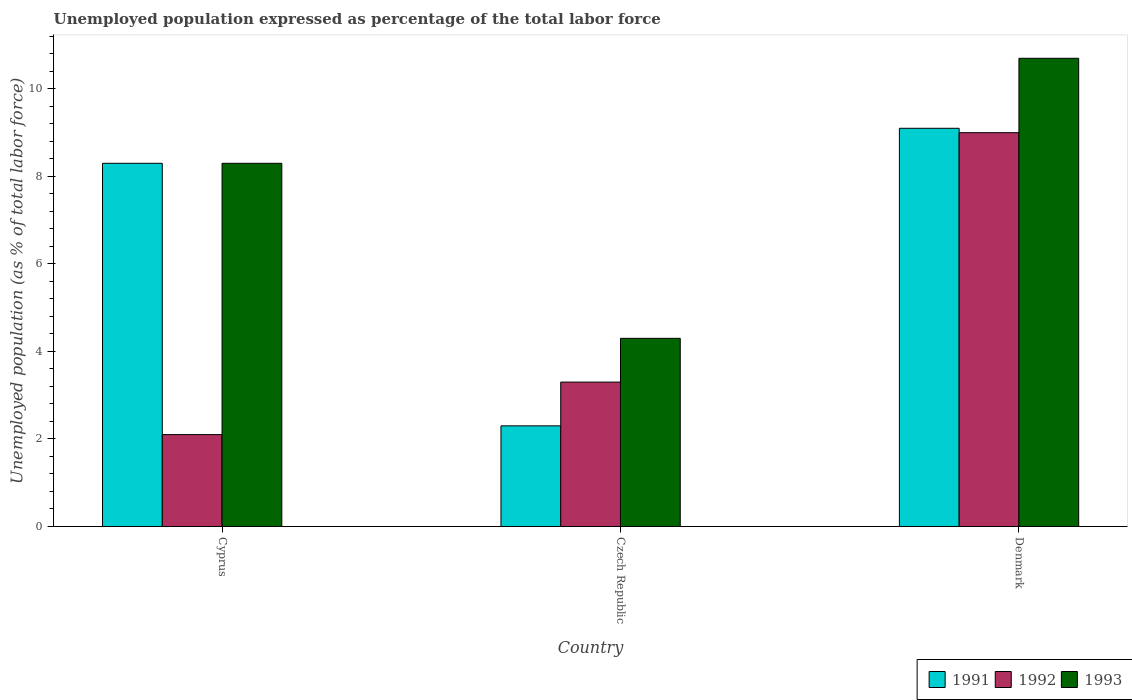How many groups of bars are there?
Offer a terse response. 3. Are the number of bars per tick equal to the number of legend labels?
Provide a succinct answer. Yes. What is the label of the 2nd group of bars from the left?
Your answer should be very brief. Czech Republic. In how many cases, is the number of bars for a given country not equal to the number of legend labels?
Your response must be concise. 0. What is the unemployment in in 1992 in Cyprus?
Offer a very short reply. 2.1. Across all countries, what is the maximum unemployment in in 1992?
Offer a very short reply. 9. Across all countries, what is the minimum unemployment in in 1992?
Provide a succinct answer. 2.1. In which country was the unemployment in in 1991 minimum?
Your answer should be compact. Czech Republic. What is the total unemployment in in 1992 in the graph?
Ensure brevity in your answer.  14.4. What is the difference between the unemployment in in 1992 in Cyprus and that in Czech Republic?
Your response must be concise. -1.2. What is the difference between the unemployment in in 1993 in Cyprus and the unemployment in in 1992 in Denmark?
Provide a succinct answer. -0.7. What is the average unemployment in in 1991 per country?
Offer a terse response. 6.57. What is the difference between the unemployment in of/in 1993 and unemployment in of/in 1992 in Cyprus?
Offer a terse response. 6.2. In how many countries, is the unemployment in in 1992 greater than 4 %?
Keep it short and to the point. 1. What is the ratio of the unemployment in in 1993 in Cyprus to that in Czech Republic?
Offer a very short reply. 1.93. Is the difference between the unemployment in in 1993 in Cyprus and Denmark greater than the difference between the unemployment in in 1992 in Cyprus and Denmark?
Ensure brevity in your answer.  Yes. What is the difference between the highest and the second highest unemployment in in 1993?
Your answer should be very brief. -2.4. What is the difference between the highest and the lowest unemployment in in 1991?
Provide a succinct answer. 6.8. In how many countries, is the unemployment in in 1991 greater than the average unemployment in in 1991 taken over all countries?
Offer a very short reply. 2. What does the 1st bar from the left in Cyprus represents?
Ensure brevity in your answer.  1991. What does the 2nd bar from the right in Denmark represents?
Your response must be concise. 1992. How many countries are there in the graph?
Offer a terse response. 3. What is the difference between two consecutive major ticks on the Y-axis?
Keep it short and to the point. 2. Are the values on the major ticks of Y-axis written in scientific E-notation?
Offer a terse response. No. Does the graph contain any zero values?
Your answer should be very brief. No. Does the graph contain grids?
Provide a succinct answer. No. Where does the legend appear in the graph?
Keep it short and to the point. Bottom right. What is the title of the graph?
Ensure brevity in your answer.  Unemployed population expressed as percentage of the total labor force. Does "1961" appear as one of the legend labels in the graph?
Provide a succinct answer. No. What is the label or title of the X-axis?
Make the answer very short. Country. What is the label or title of the Y-axis?
Offer a very short reply. Unemployed population (as % of total labor force). What is the Unemployed population (as % of total labor force) of 1991 in Cyprus?
Provide a short and direct response. 8.3. What is the Unemployed population (as % of total labor force) in 1992 in Cyprus?
Your answer should be very brief. 2.1. What is the Unemployed population (as % of total labor force) of 1993 in Cyprus?
Your answer should be very brief. 8.3. What is the Unemployed population (as % of total labor force) of 1991 in Czech Republic?
Offer a very short reply. 2.3. What is the Unemployed population (as % of total labor force) in 1992 in Czech Republic?
Provide a short and direct response. 3.3. What is the Unemployed population (as % of total labor force) in 1993 in Czech Republic?
Make the answer very short. 4.3. What is the Unemployed population (as % of total labor force) of 1991 in Denmark?
Keep it short and to the point. 9.1. What is the Unemployed population (as % of total labor force) in 1992 in Denmark?
Your answer should be very brief. 9. What is the Unemployed population (as % of total labor force) of 1993 in Denmark?
Your answer should be very brief. 10.7. Across all countries, what is the maximum Unemployed population (as % of total labor force) in 1991?
Ensure brevity in your answer.  9.1. Across all countries, what is the maximum Unemployed population (as % of total labor force) in 1992?
Your answer should be compact. 9. Across all countries, what is the maximum Unemployed population (as % of total labor force) of 1993?
Your answer should be compact. 10.7. Across all countries, what is the minimum Unemployed population (as % of total labor force) in 1991?
Ensure brevity in your answer.  2.3. Across all countries, what is the minimum Unemployed population (as % of total labor force) in 1992?
Give a very brief answer. 2.1. Across all countries, what is the minimum Unemployed population (as % of total labor force) in 1993?
Make the answer very short. 4.3. What is the total Unemployed population (as % of total labor force) of 1991 in the graph?
Offer a terse response. 19.7. What is the total Unemployed population (as % of total labor force) of 1992 in the graph?
Keep it short and to the point. 14.4. What is the total Unemployed population (as % of total labor force) of 1993 in the graph?
Keep it short and to the point. 23.3. What is the difference between the Unemployed population (as % of total labor force) of 1991 in Cyprus and that in Czech Republic?
Keep it short and to the point. 6. What is the difference between the Unemployed population (as % of total labor force) of 1992 in Cyprus and that in Czech Republic?
Ensure brevity in your answer.  -1.2. What is the difference between the Unemployed population (as % of total labor force) of 1991 in Cyprus and that in Denmark?
Your answer should be very brief. -0.8. What is the difference between the Unemployed population (as % of total labor force) in 1992 in Cyprus and that in Denmark?
Keep it short and to the point. -6.9. What is the difference between the Unemployed population (as % of total labor force) in 1991 in Czech Republic and that in Denmark?
Give a very brief answer. -6.8. What is the difference between the Unemployed population (as % of total labor force) of 1991 in Cyprus and the Unemployed population (as % of total labor force) of 1993 in Denmark?
Offer a very short reply. -2.4. What is the difference between the Unemployed population (as % of total labor force) in 1992 in Cyprus and the Unemployed population (as % of total labor force) in 1993 in Denmark?
Provide a succinct answer. -8.6. What is the difference between the Unemployed population (as % of total labor force) in 1991 in Czech Republic and the Unemployed population (as % of total labor force) in 1992 in Denmark?
Your answer should be very brief. -6.7. What is the average Unemployed population (as % of total labor force) in 1991 per country?
Offer a very short reply. 6.57. What is the average Unemployed population (as % of total labor force) of 1992 per country?
Provide a succinct answer. 4.8. What is the average Unemployed population (as % of total labor force) of 1993 per country?
Offer a very short reply. 7.77. What is the difference between the Unemployed population (as % of total labor force) of 1991 and Unemployed population (as % of total labor force) of 1993 in Cyprus?
Ensure brevity in your answer.  0. What is the difference between the Unemployed population (as % of total labor force) of 1991 and Unemployed population (as % of total labor force) of 1993 in Czech Republic?
Offer a very short reply. -2. What is the difference between the Unemployed population (as % of total labor force) in 1991 and Unemployed population (as % of total labor force) in 1993 in Denmark?
Make the answer very short. -1.6. What is the difference between the Unemployed population (as % of total labor force) of 1992 and Unemployed population (as % of total labor force) of 1993 in Denmark?
Offer a terse response. -1.7. What is the ratio of the Unemployed population (as % of total labor force) of 1991 in Cyprus to that in Czech Republic?
Ensure brevity in your answer.  3.61. What is the ratio of the Unemployed population (as % of total labor force) of 1992 in Cyprus to that in Czech Republic?
Give a very brief answer. 0.64. What is the ratio of the Unemployed population (as % of total labor force) of 1993 in Cyprus to that in Czech Republic?
Keep it short and to the point. 1.93. What is the ratio of the Unemployed population (as % of total labor force) in 1991 in Cyprus to that in Denmark?
Offer a terse response. 0.91. What is the ratio of the Unemployed population (as % of total labor force) in 1992 in Cyprus to that in Denmark?
Ensure brevity in your answer.  0.23. What is the ratio of the Unemployed population (as % of total labor force) of 1993 in Cyprus to that in Denmark?
Offer a terse response. 0.78. What is the ratio of the Unemployed population (as % of total labor force) in 1991 in Czech Republic to that in Denmark?
Provide a succinct answer. 0.25. What is the ratio of the Unemployed population (as % of total labor force) in 1992 in Czech Republic to that in Denmark?
Provide a short and direct response. 0.37. What is the ratio of the Unemployed population (as % of total labor force) in 1993 in Czech Republic to that in Denmark?
Your answer should be compact. 0.4. What is the difference between the highest and the second highest Unemployed population (as % of total labor force) of 1991?
Your answer should be very brief. 0.8. What is the difference between the highest and the second highest Unemployed population (as % of total labor force) of 1993?
Your answer should be very brief. 2.4. 